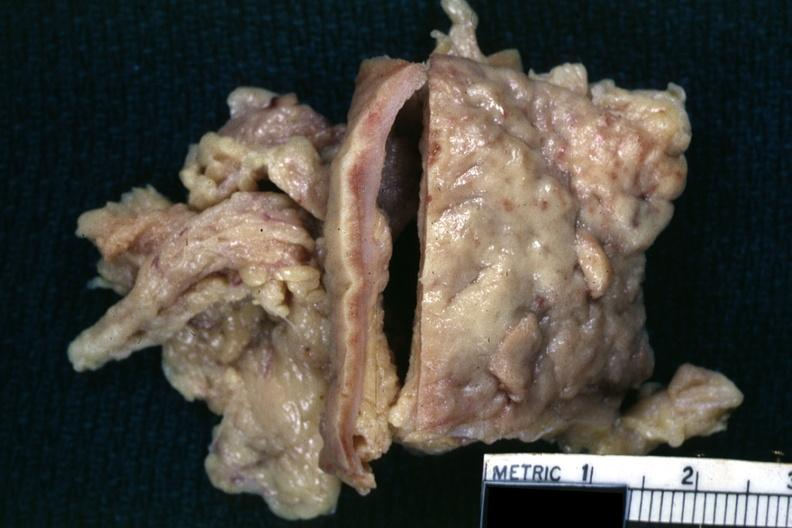s tuberculosis present?
Answer the question using a single word or phrase. Yes 